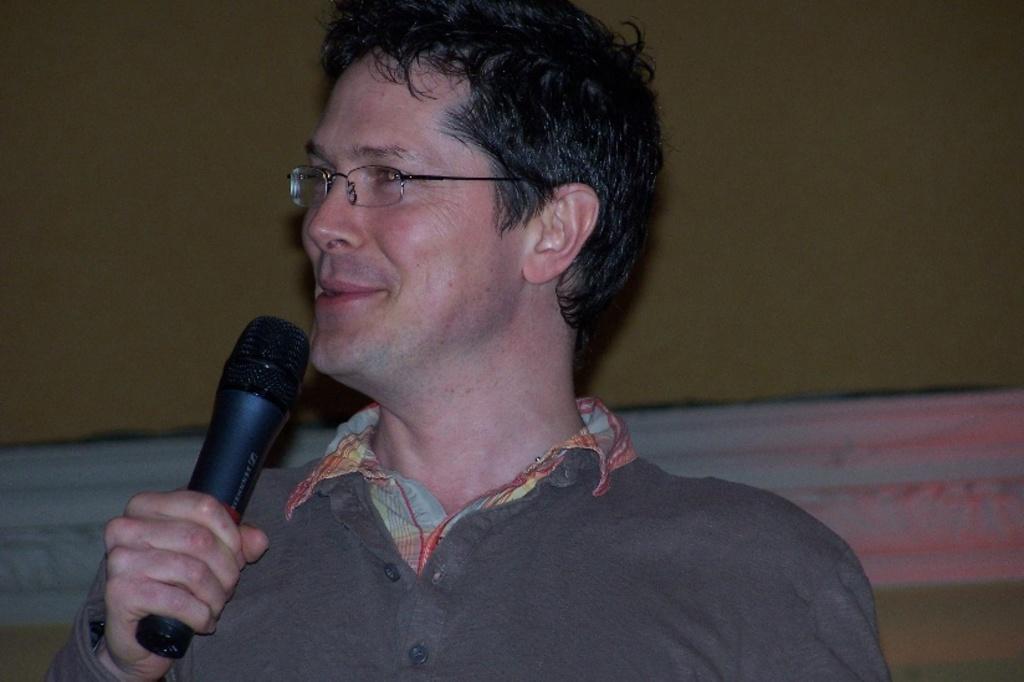Could you give a brief overview of what you see in this image? In this image we can see a person holding a mike, back of him there is a wall. 